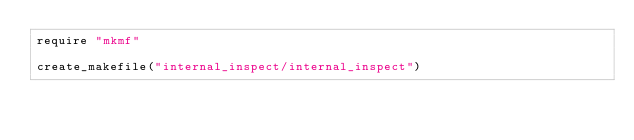Convert code to text. <code><loc_0><loc_0><loc_500><loc_500><_Ruby_>require "mkmf"

create_makefile("internal_inspect/internal_inspect")
</code> 